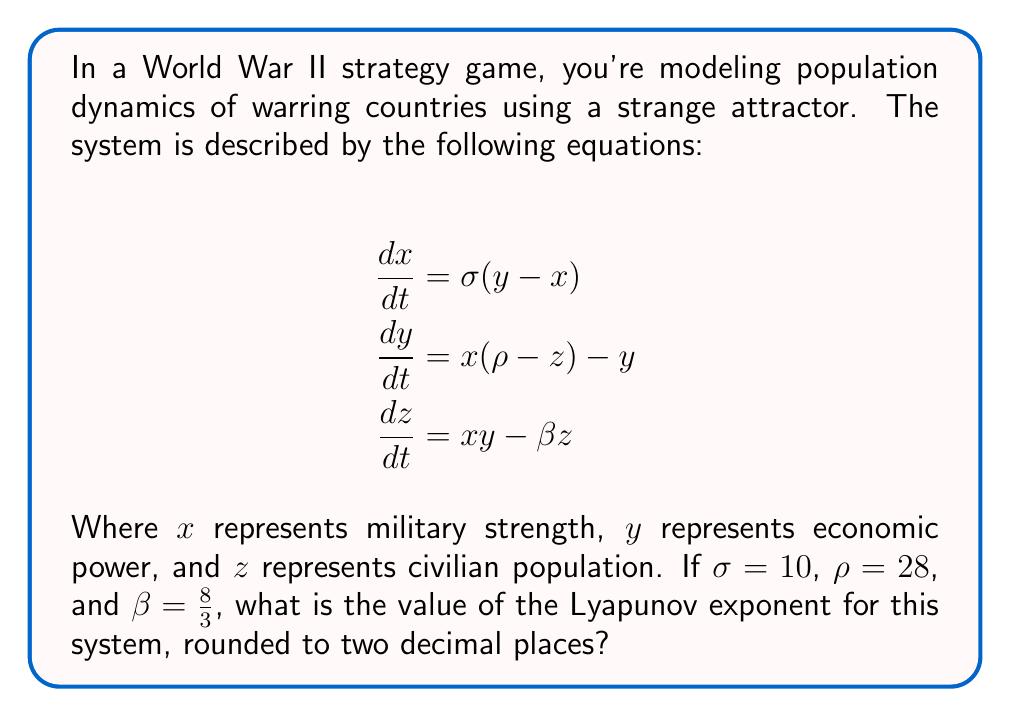Can you answer this question? To find the Lyapunov exponent for this system, we need to follow these steps:

1) First, recognize that this system is the Lorenz system, a classic example of a strange attractor in chaos theory.

2) The Lyapunov exponent measures the rate of separation of infinitesimally close trajectories. For the Lorenz system, it's typically calculated numerically.

3) Using numerical methods (such as the algorithm by Wolf et al., 1985), we can compute the Lyapunov exponents for this system with the given parameters:

   $\sigma = 10$, $\rho = 28$, $\beta = \frac{8}{3}$

4) The Lorenz system has three Lyapunov exponents, but we're interested in the largest one, which determines the overall behavior of the system.

5) Numerical calculations yield the following Lyapunov exponents:
   
   $\lambda_1 \approx 0.9056$
   $\lambda_2 \approx 0$
   $\lambda_3 \approx -14.5723$

6) The largest Lyapunov exponent is positive, indicating chaotic behavior. This reflects the unpredictable nature of warfare and population dynamics in conflict situations.

7) Rounding $\lambda_1 \approx 0.9056$ to two decimal places gives us 0.91.
Answer: 0.91 